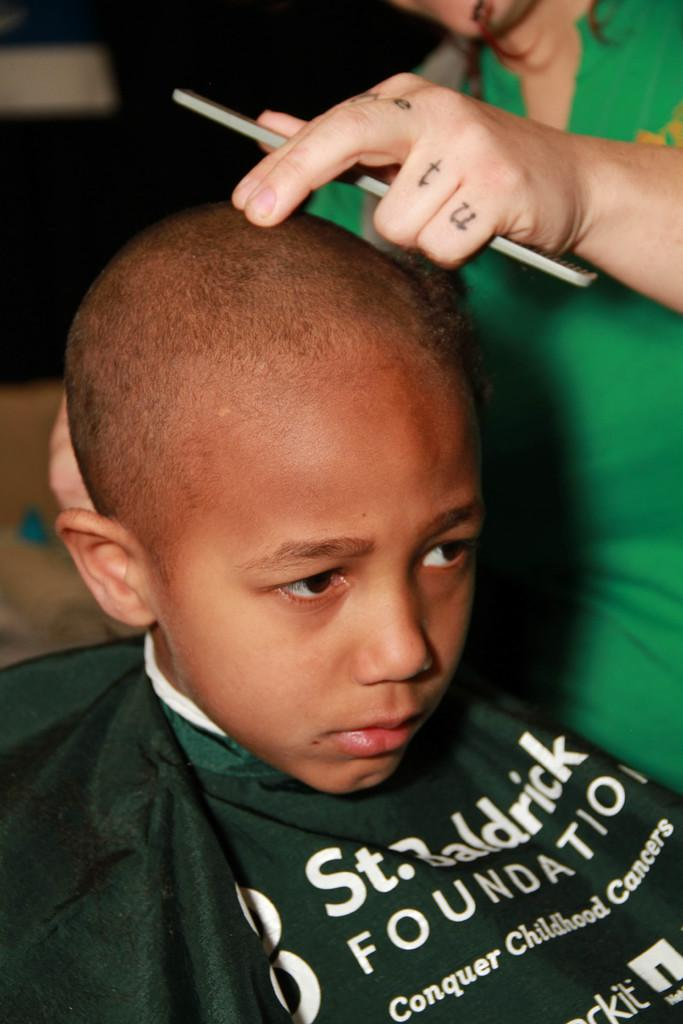Who is the main subject in the image? There is a boy in the image. What is the boy wearing? The boy is wearing a cloth. Can you describe the cloth? There is writing on the cloth. What is the person in the image holding? The person is holding a comb. What is the position of the person holding the comb? The person is standing. How would you describe the background of the image? The background of the image is blurred. What type of toy is the boy playing with in the image? There is no toy present in the image; the boy is wearing a cloth with writing on it. What is the daughter doing in the image? There is no mention of a daughter in the image; the main subject is a boy. 